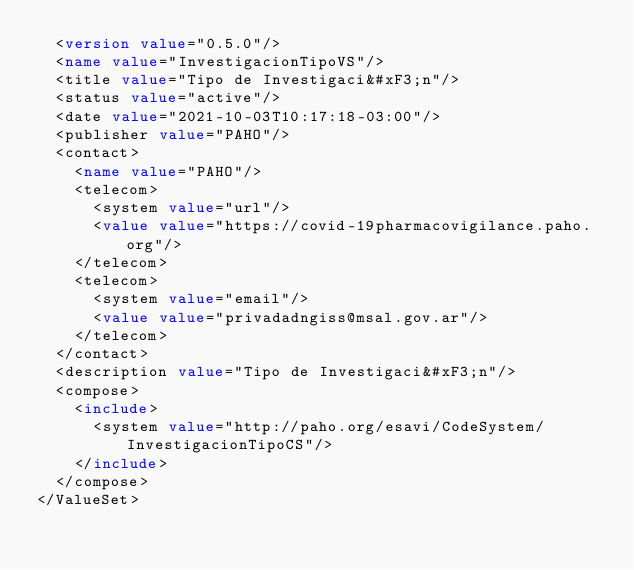Convert code to text. <code><loc_0><loc_0><loc_500><loc_500><_XML_>  <version value="0.5.0"/>
  <name value="InvestigacionTipoVS"/>
  <title value="Tipo de Investigaci&#xF3;n"/>
  <status value="active"/>
  <date value="2021-10-03T10:17:18-03:00"/>
  <publisher value="PAHO"/>
  <contact>
    <name value="PAHO"/>
    <telecom>
      <system value="url"/>
      <value value="https://covid-19pharmacovigilance.paho.org"/>
    </telecom>
    <telecom>
      <system value="email"/>
      <value value="privadadngiss@msal.gov.ar"/>
    </telecom>
  </contact>
  <description value="Tipo de Investigaci&#xF3;n"/>
  <compose>
    <include>
      <system value="http://paho.org/esavi/CodeSystem/InvestigacionTipoCS"/>
    </include>
  </compose>
</ValueSet></code> 